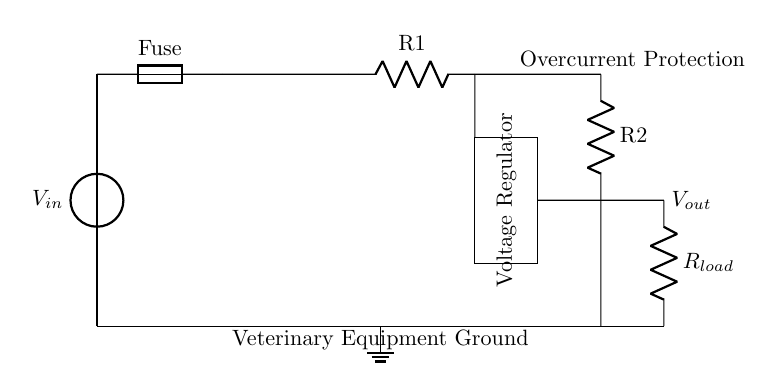What is the input voltage in this circuit? The input voltage is represented by the symbol V in the circuit diagram. It is located at the top left and is labeled as $V_{in}$. This indicates the source of electrical energy feeding into the circuit.
Answer: V in What is the purpose of the fuse? The fuse serves as a protective component that interrupts the circuit in case of overcurrent. It is crucial for preventing damage to the other components like the voltage regulator and load. It is specifically located between the voltage source and the rest of the circuit.
Answer: Protection How many resistors are present in this circuit? Upon examining the diagram, there are two resistors labeled as R1 and R2. They are depicted in separate locations within the circuit, with R1 above and R2 below. The counting of components shows that indeed there are two resistors in total.
Answer: Two What component regulates the output voltage? The regulator is the component that ensures a stable output voltage. It is depicted as a rectangle between R1 and Rload in the diagram. This signifies it takes the input and adjusts it to a desired output level, regardless of variations in load.
Answer: Voltage Regulator What would happen if the fuse blows? If the fuse blows, it will break the circuit and stop the flow of current. This means all subsequent components, including the voltage regulator and the load, will not function until the fuse is replaced. This reaction is critical for avoiding damages due to excessive current.
Answer: Circuit stops What does Rload represent in this circuit? Rload represents the load resistance that the veterinary medical equipment requires to operate. It is placed towards the output side of the circuit, indicating that it is where the finished voltage is delivered for usage.
Answer: Load resistance What does the ground symbol indicate? The ground symbol indicates a reference point for the electrical potential in the circuit. In this case, it serves as the common return path for current, ensuring safety and proper operation for the veterinary equipment being powered.
Answer: Common return 